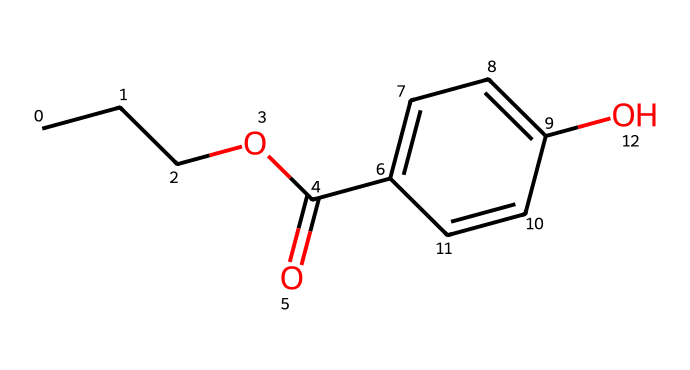What is the total number of carbon atoms in propylparaben? By analyzing the SMILES representation, we can identify that "CCCO" indicates three carbon atoms in the propyl chain, and "C1=CC" indicates an aromatic ring that contributes four additional carbon atoms. Therefore, the total number of carbon atoms is 7.
Answer: 7 How many oxygen atoms are present in propylparaben? From the SMILES structure, we can observe the presence of two oxygen atoms: one in the ester functional group (indicated by "O") and another in the hydroxyl group ("O"). Therefore, there are two oxygen atoms in total.
Answer: 2 What type of functional group is present in propylparaben? The SMILES shows "C(=O)", characteristic of an ester (indicating the presence of a carbonyl group separated by an alkoxy group), and "O" in "OCC" signifies it is part of an ester structure. Thus, the functional group is an ester.
Answer: ester Does this compound contain any double bonds? Examining the SMILES representation reveals "C=C" in the benzene ring, indicating a carbon-carbon double bond within the aromatic structure, which confirms the presence of double bonds.
Answer: yes How many aromatic rings are found in propylparaben? The structure exhibits a specific pattern where "C1=CC=C(C=C1)" indicates a closed ring structure made entirely of carbon atoms, signifying one aromatic ring is present.
Answer: 1 Is propylparaben hydrophilic or hydrophobic? Given its structure, the presence of hydroxyl (-OH) makes it partially hydrophilic, though the long carbon chain (propyl group) contributes to hydrophobic characteristics. Overall, propylparaben is considered amphipathic but leans towards hydrophobic due to its alkyl chain dominance.
Answer: amphipathic 